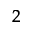<formula> <loc_0><loc_0><loc_500><loc_500>_ { 2 }</formula> 